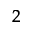<formula> <loc_0><loc_0><loc_500><loc_500>_ { 2 }</formula> 